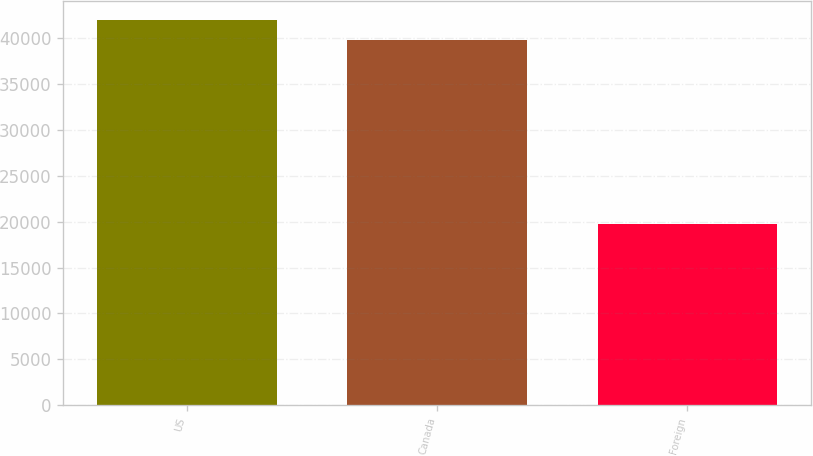Convert chart to OTSL. <chart><loc_0><loc_0><loc_500><loc_500><bar_chart><fcel>US<fcel>Canada<fcel>Foreign<nl><fcel>41978.1<fcel>39822<fcel>19706<nl></chart> 